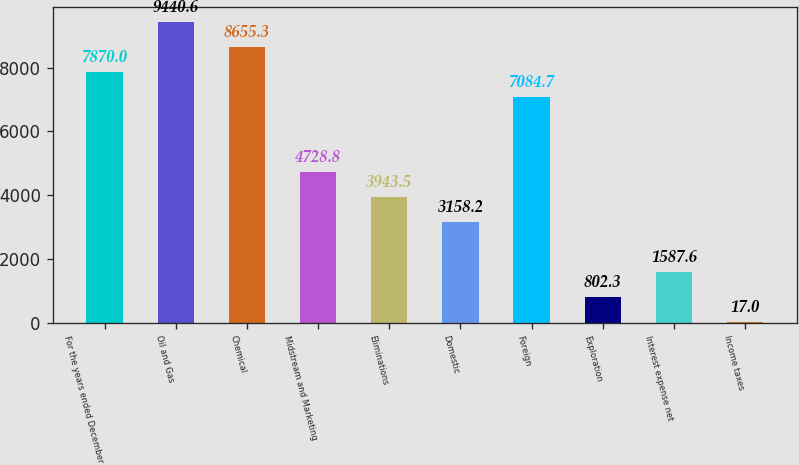Convert chart. <chart><loc_0><loc_0><loc_500><loc_500><bar_chart><fcel>For the years ended December<fcel>Oil and Gas<fcel>Chemical<fcel>Midstream and Marketing<fcel>Eliminations<fcel>Domestic<fcel>Foreign<fcel>Exploration<fcel>Interest expense net<fcel>Income taxes<nl><fcel>7870<fcel>9440.6<fcel>8655.3<fcel>4728.8<fcel>3943.5<fcel>3158.2<fcel>7084.7<fcel>802.3<fcel>1587.6<fcel>17<nl></chart> 